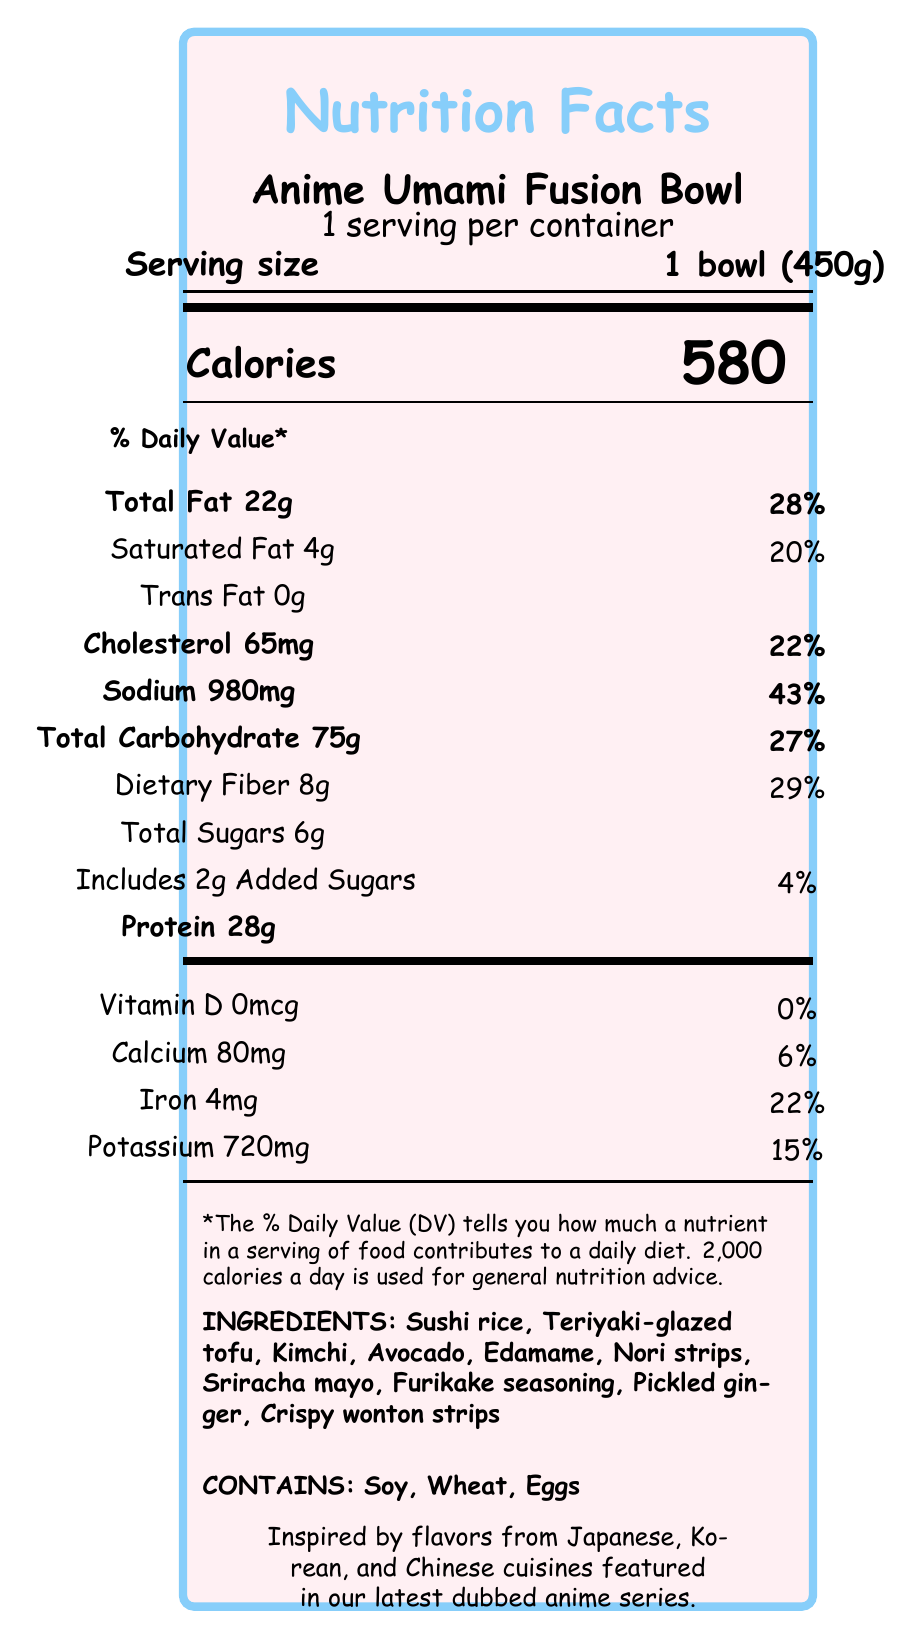what is the serving size of the Anime Umami Fusion Bowl? The serving size is explicitly stated in the document as "1 bowl (450g)".
Answer: 1 bowl (450g) how many calories are in a serving of the Anime Umami Fusion Bowl? The document indicates there are 580 calories per serving.
Answer: 580 what is the total fat content and its daily value percentage? The document states the total fat content is 22g, which is 28% of the daily value.
Answer: 22g, 28% what are the main ingredients listed in the Anime Umami Fusion Bowl? The ingredients are listed near the bottom of the document.
Answer: Sushi rice, Teriyaki-glazed tofu, Kimchi, Avocado, Edamame, Nori strips, Sriracha mayo, Furikake seasoning, Pickled ginger, Crispy wonton strips how much protein does the Anime Umami Fusion Bowl contain? The document specifies that the bowl contains 28g of protein.
Answer: 28g what are the allergens present in the Anime Umami Fusion Bowl? The allergens are listed as Soy, Wheat, and Eggs in the document.
Answer: Soy, Wheat, Eggs what is the cholesterol content and its daily value percentage? The document notes that the cholesterol content is 65mg, which is 22% of the daily value.
Answer: 65mg, 22% how much sodium is in the Anime Umami Fusion Bowl? The document states that the sodium content is 980mg.
Answer: 980mg what percentage of the daily value of dietary fiber is in the Anime Umami Fusion Bowl? The document shows that the dietary fiber content is 8g, which is 29% of the daily value.
Answer: 29% how many grams of added sugars does the Anime Umami Fusion Bowl contain? a. 0g b. 2g c. 6g d. 8g The document indicates that the bowl contains 2g of added sugars.
Answer: b. 2g what is the main source of protein in the Anime Umami Fusion Bowl? a. Kimchi b. Avocado c. Teriyaki-glazed tofu d. Nori strips The document lists Teriyaki-glazed tofu, which is known to be high in protein.
Answer: c. Teriyaki-glazed tofu is there any Vitamin D in the Anime Umami Fusion Bowl? The document states there is 0mcg of Vitamin D, which means none is present.
Answer: No summarize the key nutritional information of the Anime Umami Fusion Bowl. This summary condenses the primary nutritional information, highlighting calorie content, macronutrients, and daily value percentages for various nutrients.
Answer: The Anime Umami Fusion Bowl contains 580 calories per serving, with 22g of total fat (28% DV), 4g of saturated fat (20% DV), 0g of trans fat, 65mg of cholesterol (22% DV), 980mg of sodium (43% DV), 75g of total carbohydrates (27% DV), 8g of dietary fiber (29% DV), 6g of total sugars (including 2g of added sugars, 4% DV), and 28g of protein. It also includes various vitamins and minerals with specific daily values provided. what is the dietary fiber content in grams? The document specifies that the dietary fiber content is 8g.
Answer: 8g what is the source of potassium in the Anime Umami Fusion Bowl? The document lists the amount of potassium but does not specify the source.
Answer: Not enough information 